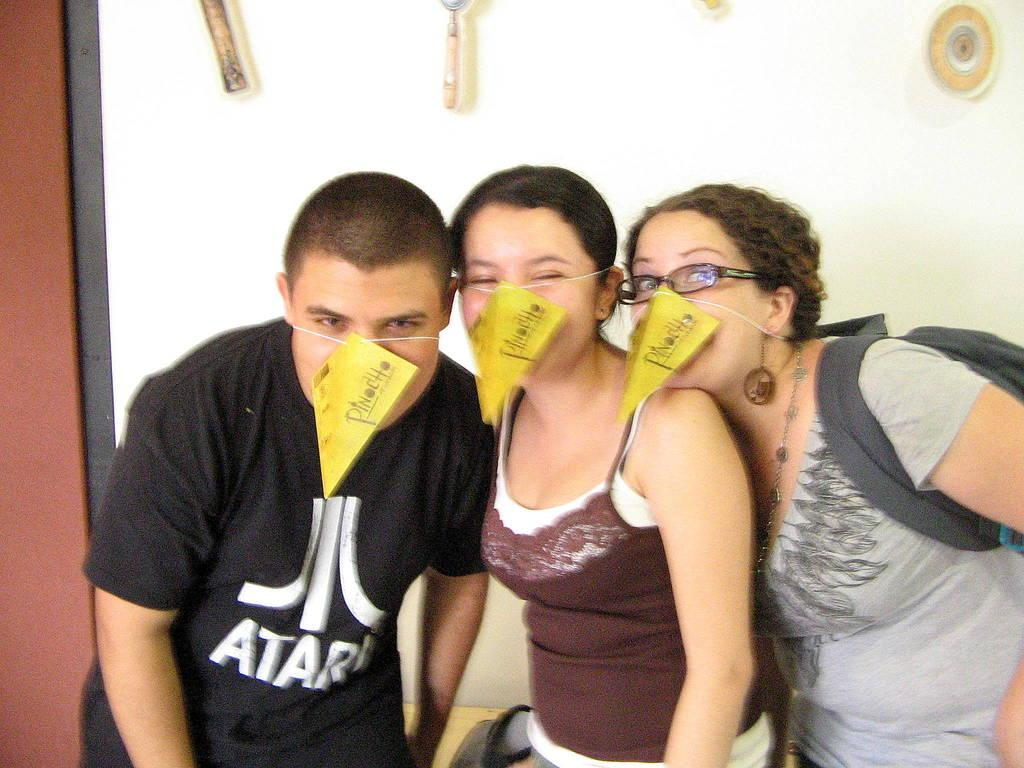How many people are present in the image? There are three people in the image. What are the people wearing on their faces? The people are wearing masks. What can be seen in the background of the image? There is a wall in the background of the image. What is placed on the wall? Decorations are placed on the wall. Where is the desk located in the image? There is no desk present in the image. What type of kite is being flown by the people in the image? There are no kites present in the image; the people are wearing masks. 